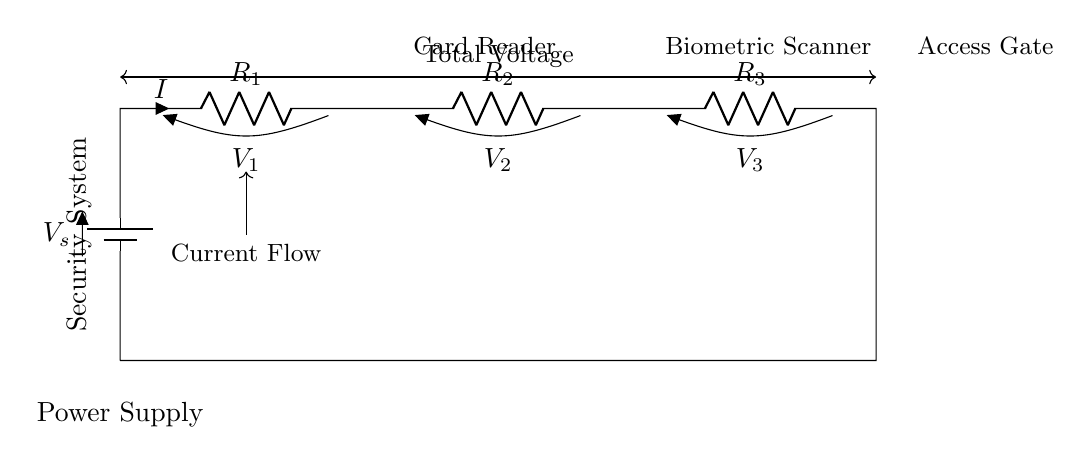What is the total voltage supplied in the circuit? The total voltage supplied is represented as V_s in the circuit diagram. This value is typically specified by the power supply connected at the top of the circuit.
Answer: V_s What components are in series in this circuit? The components in series include the resistor R_1, R_2, and R_3, connected one after the other. Each resistor affects the total resistance and current in the series circuit.
Answer: R_1, R_2, R_3 What does the current flow direction indicate? The current flow direction is shown by the arrow labeled I, which points from the power supply through the resistors and back to the supply. This indicates the direction in which electrons flow through the circuit.
Answer: Current flow direction is indicated by I What is the role of the card reader in the circuit? The card reader acts as an access control device that uses an electric signal to allow or deny entry based on valid card information. It is connected to the power supply through the resistors for its operation.
Answer: Access control device Which component has the highest voltage drop? The voltage drop across each resistor can vary based on their resistances, but without specific values, we can assume that the one in series with the highest resistance will have the highest voltage drop. In this case, if R_1 > R_2 > R_3, then R_1 would have the highest drop.
Answer: Resistor with highest resistance How does the series configuration affect the total current in the circuit? In a series circuit, the total current is the same through all components, determined by the total voltage supplied divided by the total resistance (Ohm’s Law). Because all components share the same current path, they all experience the same current.
Answer: Total current is the same 